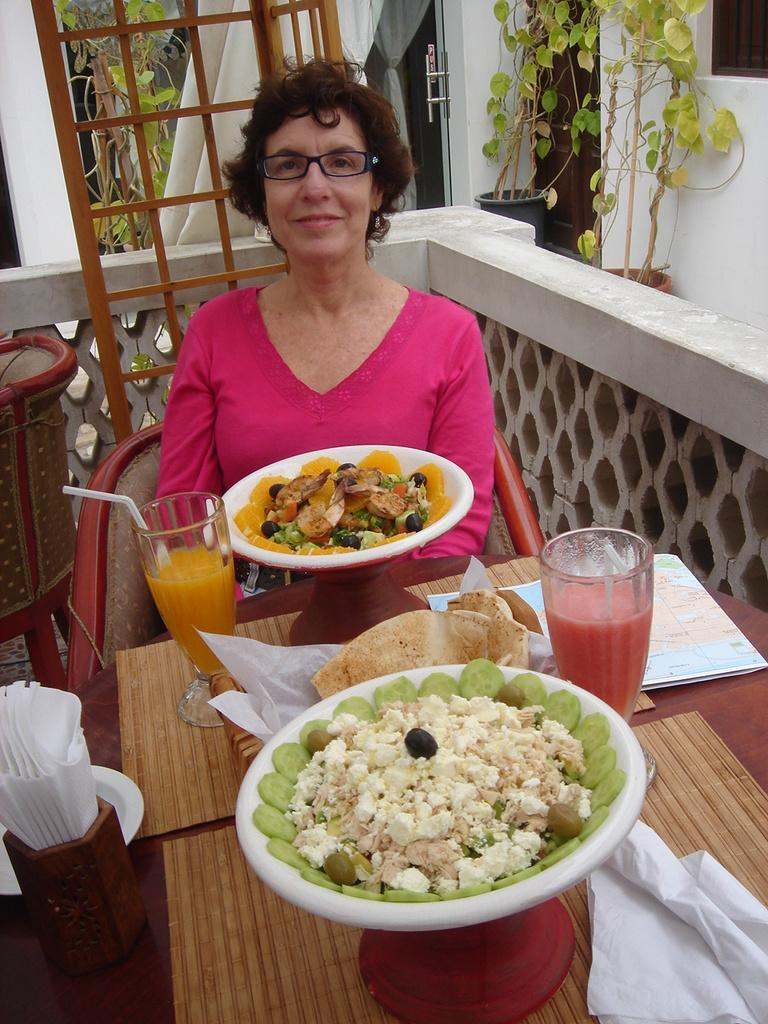What is the woman in the image doing? The woman is sitting on a chair in the image. What is the woman wearing? The woman is wearing a pink dress and spectacles. What can be seen on the dining table in the image? There are food items on a dining table in the image. What is present on the right side of the image? There are plants on the right side of the image. What type of hook can be seen hanging from the ceiling in the image? There is no hook visible in the image; it only features a woman sitting on a chair, food items on a dining table, and plants on the right side. 